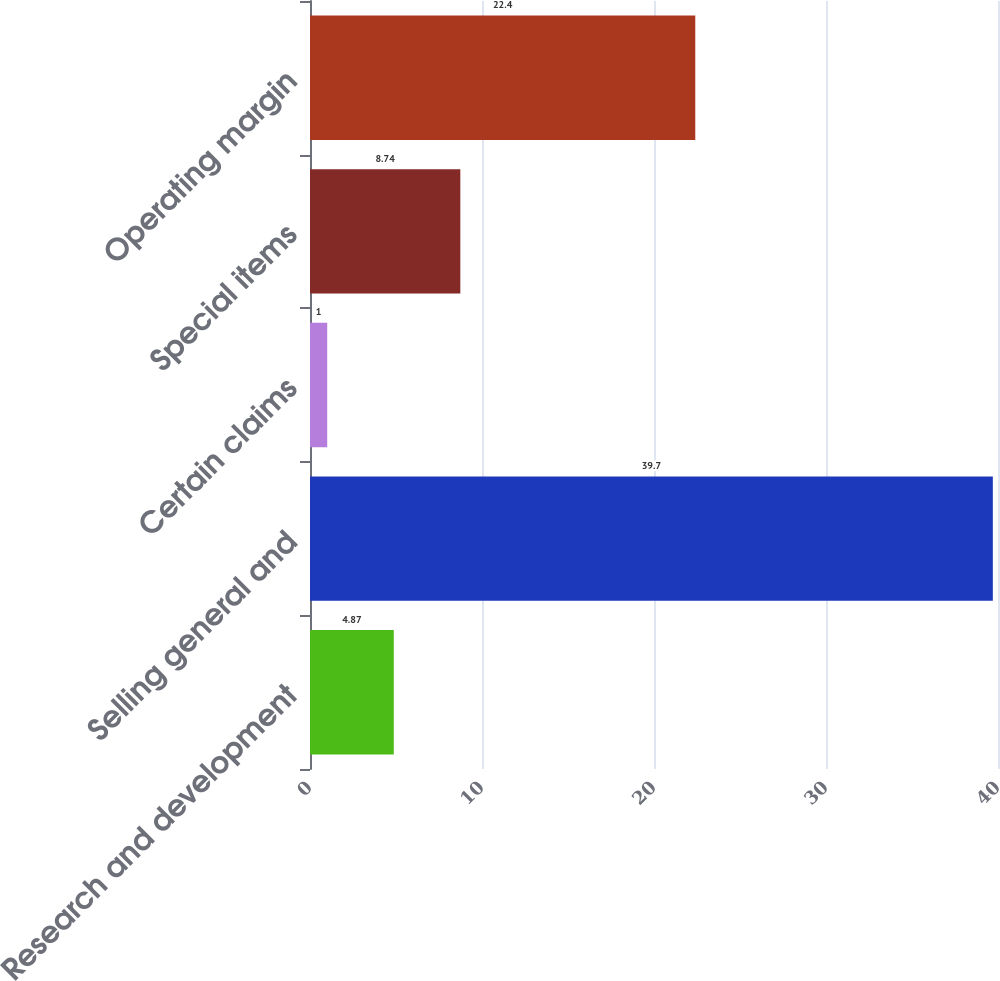Convert chart to OTSL. <chart><loc_0><loc_0><loc_500><loc_500><bar_chart><fcel>Research and development<fcel>Selling general and<fcel>Certain claims<fcel>Special items<fcel>Operating margin<nl><fcel>4.87<fcel>39.7<fcel>1<fcel>8.74<fcel>22.4<nl></chart> 